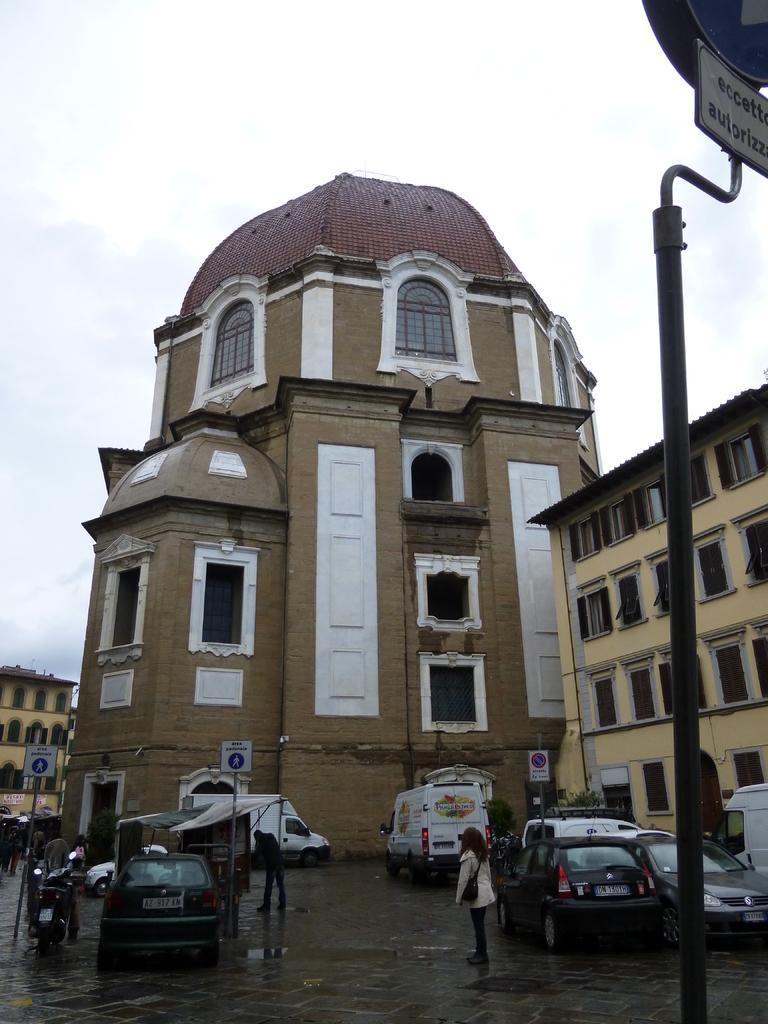Describe this image in one or two sentences. Bottom right side of the image there is a pole and sign board. Behind the pole there are some vehicles on the road. Bottom left side of the image there are some sign boards and few people are standing. In the middle of the image there are some buildings. Behind the buildings there are some clouds and sky. 